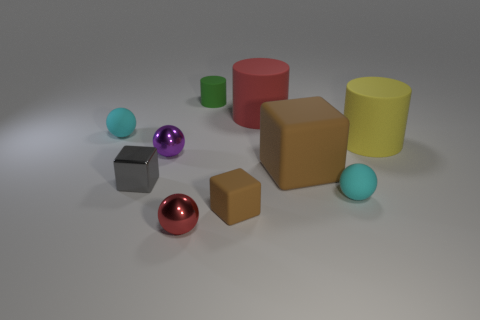Is the number of small brown matte objects that are to the left of the red metal ball greater than the number of green matte things in front of the yellow thing?
Offer a very short reply. No. There is another rubber cylinder that is the same size as the red cylinder; what is its color?
Ensure brevity in your answer.  Yellow. Are there any small shiny spheres of the same color as the metal block?
Provide a short and direct response. No. Is the color of the small block that is on the right side of the green matte cylinder the same as the small sphere that is to the right of the large brown rubber block?
Your response must be concise. No. What is the material of the red thing in front of the purple metal thing?
Your answer should be compact. Metal. The cube that is the same material as the red sphere is what color?
Ensure brevity in your answer.  Gray. What number of other rubber objects have the same size as the yellow matte object?
Keep it short and to the point. 2. Do the metal ball behind the red ball and the big yellow thing have the same size?
Ensure brevity in your answer.  No. What shape is the tiny object that is in front of the small gray shiny thing and left of the small green thing?
Make the answer very short. Sphere. Are there any green matte cylinders in front of the purple metallic thing?
Provide a short and direct response. No. 